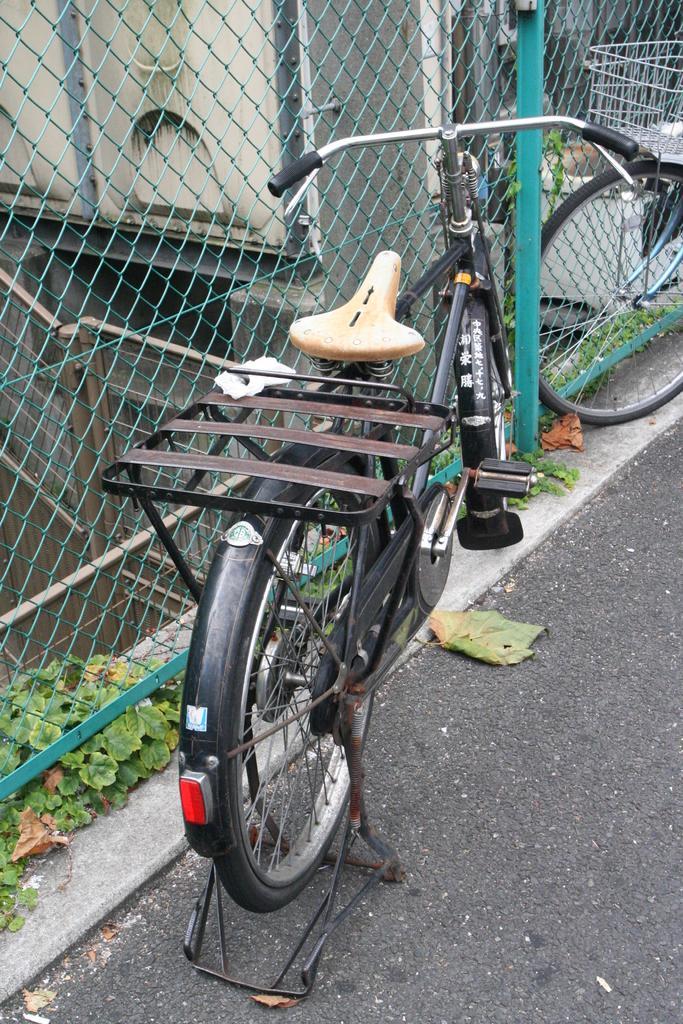Can you describe this image briefly? In this picture there is a bicycle near to the fencing and plants. In the bottom left corner we can see the leaves. At the bottom there is a road. On the left we can see the gate, water pipes and other objects. On the right we can see another bicycle which is parked near the pipe. 